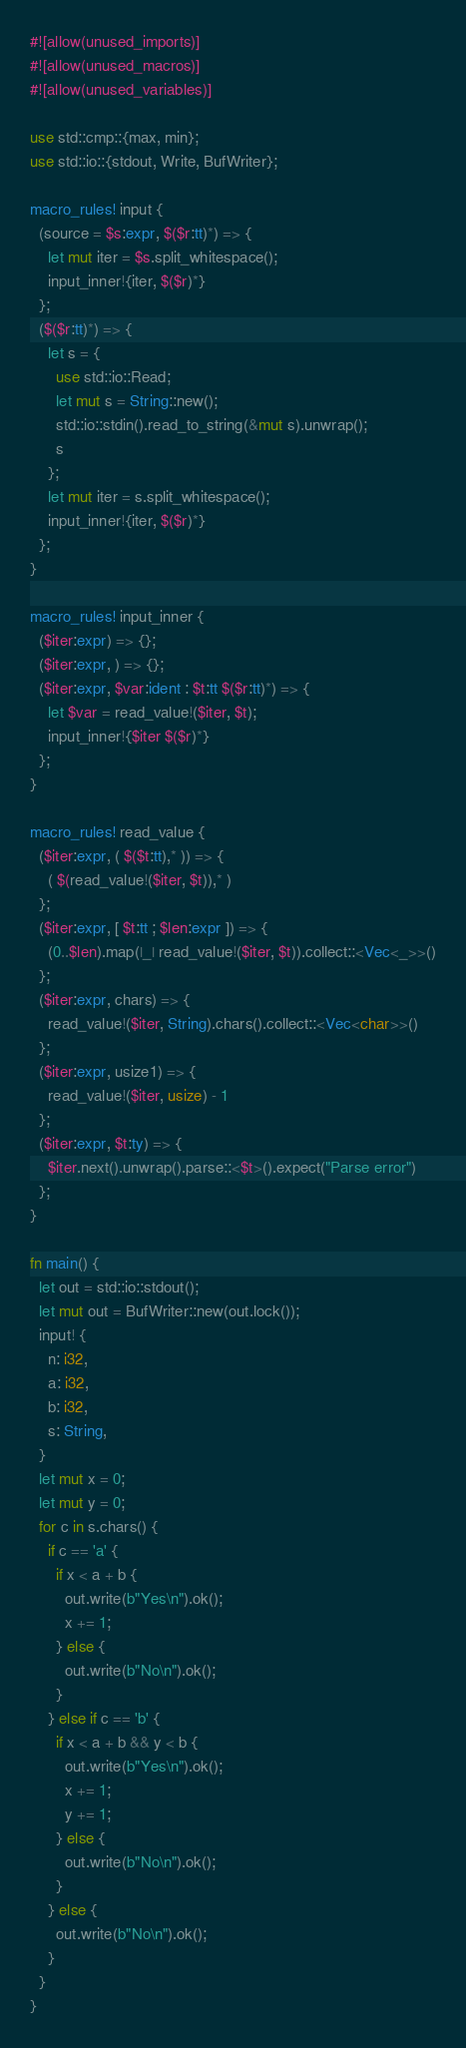<code> <loc_0><loc_0><loc_500><loc_500><_Rust_>#![allow(unused_imports)]
#![allow(unused_macros)]
#![allow(unused_variables)]

use std::cmp::{max, min};
use std::io::{stdout, Write, BufWriter};

macro_rules! input {
  (source = $s:expr, $($r:tt)*) => {
    let mut iter = $s.split_whitespace();
    input_inner!{iter, $($r)*}
  };
  ($($r:tt)*) => {
    let s = {
      use std::io::Read;
      let mut s = String::new();
      std::io::stdin().read_to_string(&mut s).unwrap();
      s
    };
    let mut iter = s.split_whitespace();
    input_inner!{iter, $($r)*}
  };
}

macro_rules! input_inner {
  ($iter:expr) => {};
  ($iter:expr, ) => {};
  ($iter:expr, $var:ident : $t:tt $($r:tt)*) => {
    let $var = read_value!($iter, $t);
    input_inner!{$iter $($r)*}
  };
}

macro_rules! read_value {
  ($iter:expr, ( $($t:tt),* )) => {
    ( $(read_value!($iter, $t)),* )
  };
  ($iter:expr, [ $t:tt ; $len:expr ]) => {
    (0..$len).map(|_| read_value!($iter, $t)).collect::<Vec<_>>()
  };
  ($iter:expr, chars) => {
    read_value!($iter, String).chars().collect::<Vec<char>>()
  };
  ($iter:expr, usize1) => {
    read_value!($iter, usize) - 1
  };
  ($iter:expr, $t:ty) => {
    $iter.next().unwrap().parse::<$t>().expect("Parse error")
  };
}

fn main() {
  let out = std::io::stdout();
  let mut out = BufWriter::new(out.lock());
  input! {
    n: i32,
    a: i32,
    b: i32,
    s: String,
  }
  let mut x = 0;
  let mut y = 0;
  for c in s.chars() {
    if c == 'a' {
      if x < a + b {
        out.write(b"Yes\n").ok();
        x += 1;
      } else {
        out.write(b"No\n").ok();
      }
    } else if c == 'b' {
      if x < a + b && y < b {
        out.write(b"Yes\n").ok();
        x += 1;
        y += 1;
      } else {
        out.write(b"No\n").ok();
      }
    } else {
      out.write(b"No\n").ok();
    }
  }
}
</code> 